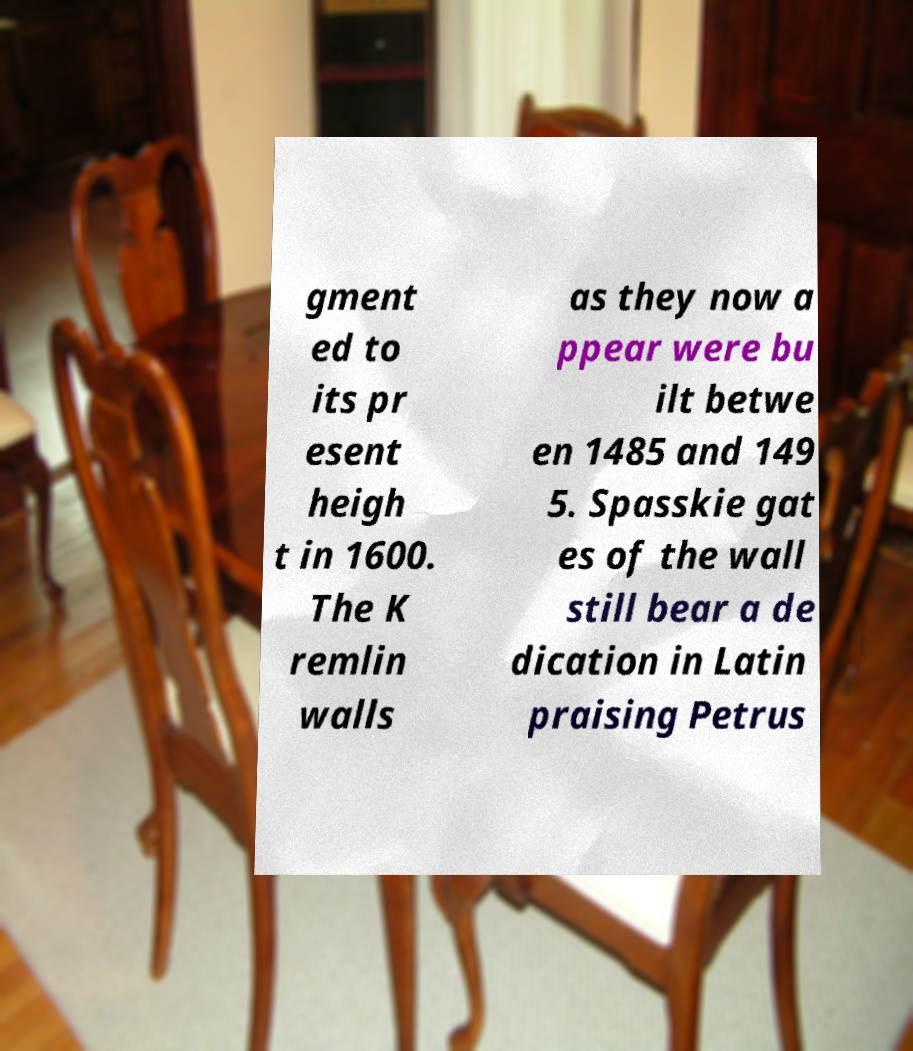Please read and relay the text visible in this image. What does it say? gment ed to its pr esent heigh t in 1600. The K remlin walls as they now a ppear were bu ilt betwe en 1485 and 149 5. Spasskie gat es of the wall still bear a de dication in Latin praising Petrus 